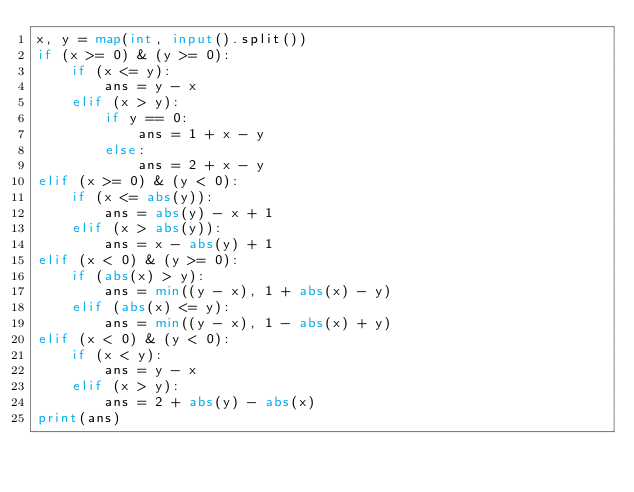<code> <loc_0><loc_0><loc_500><loc_500><_Python_>x, y = map(int, input().split())
if (x >= 0) & (y >= 0):
    if (x <= y):
        ans = y - x
    elif (x > y):
        if y == 0:
            ans = 1 + x - y
        else:
            ans = 2 + x - y
elif (x >= 0) & (y < 0):
    if (x <= abs(y)):
        ans = abs(y) - x + 1
    elif (x > abs(y)):
        ans = x - abs(y) + 1
elif (x < 0) & (y >= 0):
    if (abs(x) > y):
        ans = min((y - x), 1 + abs(x) - y)
    elif (abs(x) <= y):
        ans = min((y - x), 1 - abs(x) + y)
elif (x < 0) & (y < 0):
    if (x < y):
        ans = y - x
    elif (x > y):
        ans = 2 + abs(y) - abs(x)
print(ans)</code> 